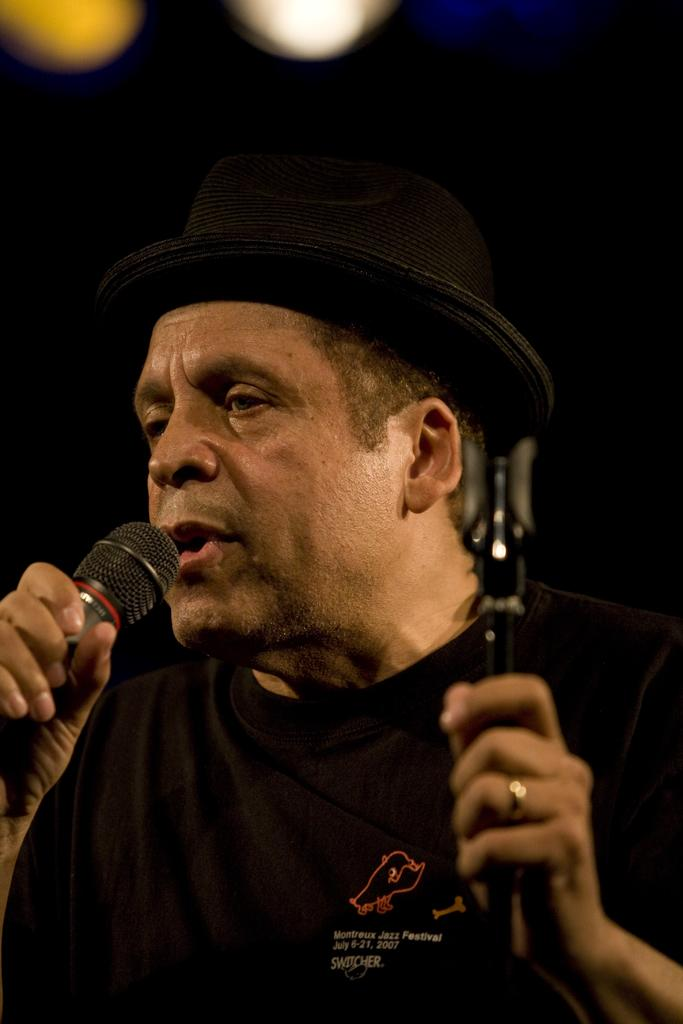What is the man in the image doing? The man is singing. What is the man holding in the image? The man is holding a mic. What type of badge is the man wearing in the image? There is no badge visible on the man in the image. What is the man's sister doing in the image? There is no mention of a sister or any other person in the image besides the man. 